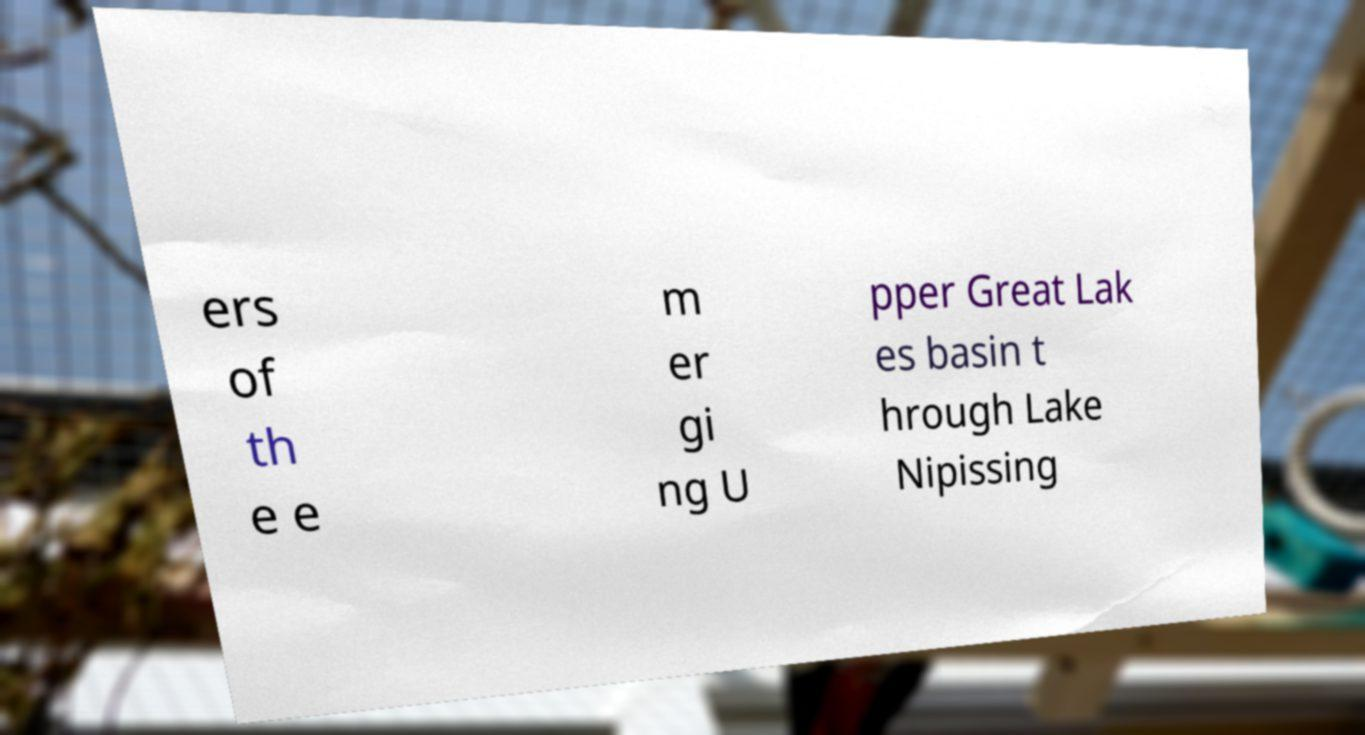Can you accurately transcribe the text from the provided image for me? ers of th e e m er gi ng U pper Great Lak es basin t hrough Lake Nipissing 